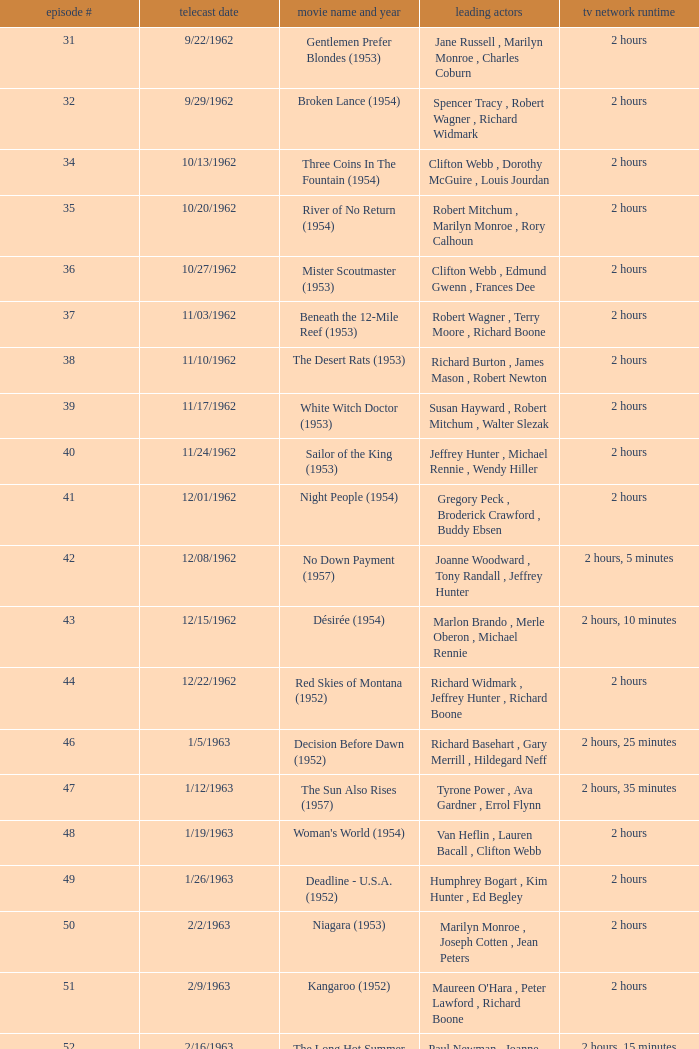How many runtimes does episode 53 have? 1.0. 